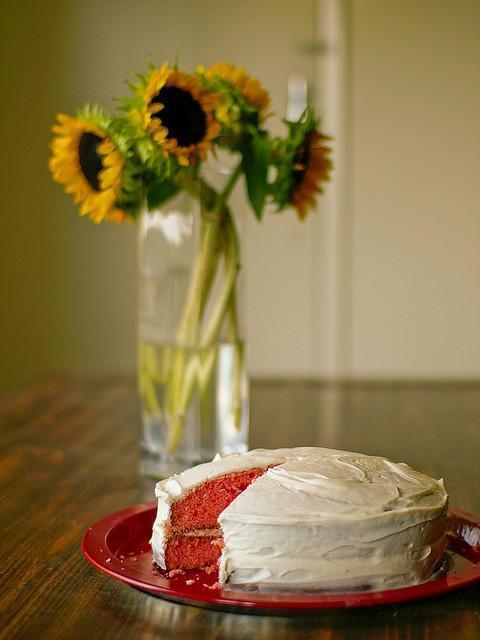How many people are wearing white hats in the picture?
Give a very brief answer. 0. 